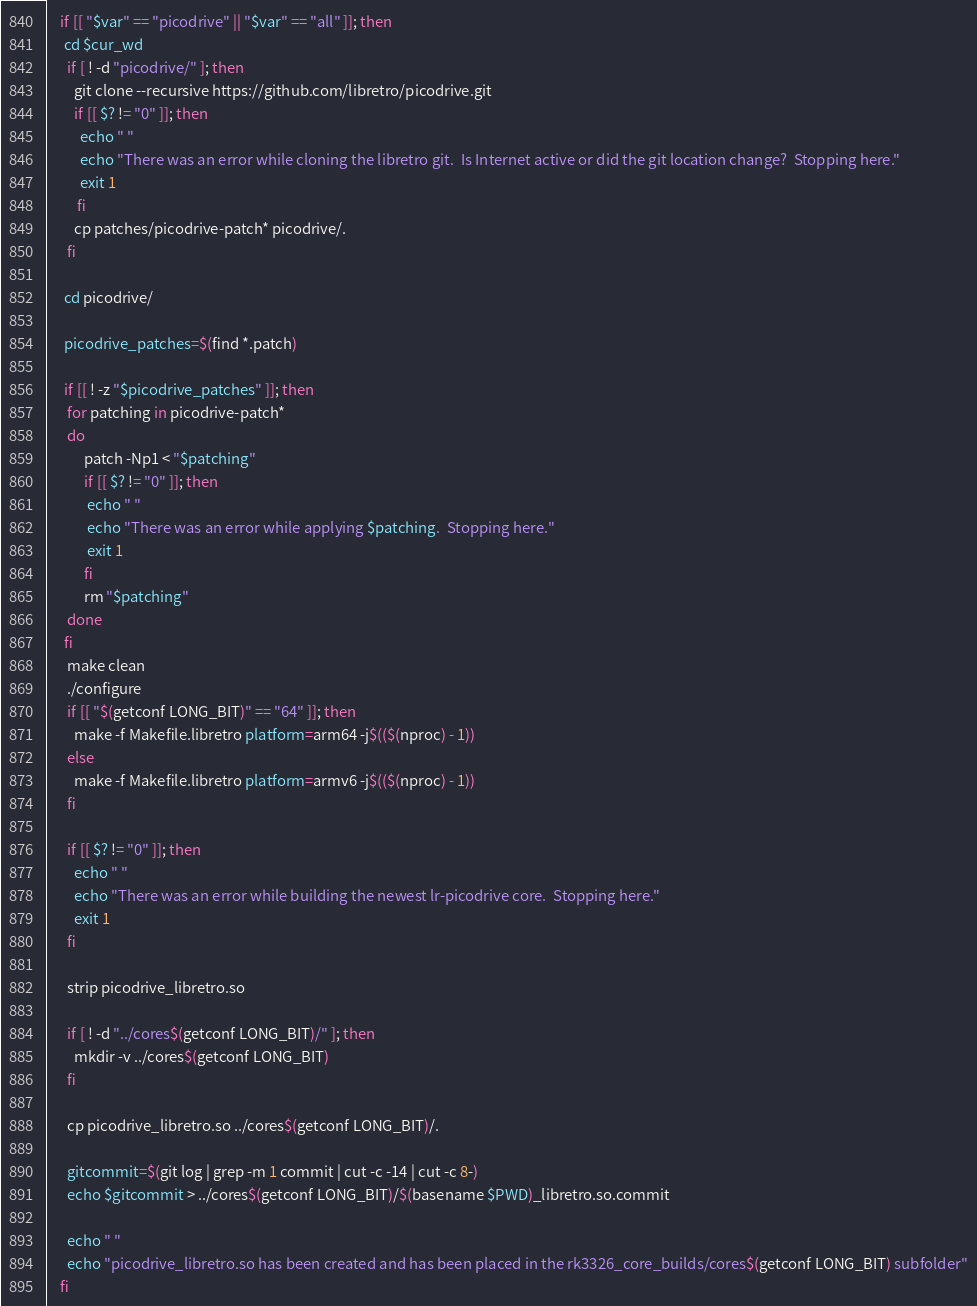Convert code to text. <code><loc_0><loc_0><loc_500><loc_500><_Bash_>	if [[ "$var" == "picodrive" || "$var" == "all" ]]; then
	 cd $cur_wd
	  if [ ! -d "picodrive/" ]; then
		git clone --recursive https://github.com/libretro/picodrive.git
		if [[ $? != "0" ]]; then
		  echo " "
		  echo "There was an error while cloning the libretro git.  Is Internet active or did the git location change?  Stopping here."
		  exit 1
		 fi
		cp patches/picodrive-patch* picodrive/.
	  fi

	 cd picodrive/
	 
	 picodrive_patches=$(find *.patch)
	 
	 if [[ ! -z "$picodrive_patches" ]]; then
	  for patching in picodrive-patch*
	  do
		   patch -Np1 < "$patching"
		   if [[ $? != "0" ]]; then
			echo " "
			echo "There was an error while applying $patching.  Stopping here."
			exit 1
		   fi
		   rm "$patching" 
	  done
	 fi
	  make clean
      ./configure
	  if [[ "$(getconf LONG_BIT)" == "64" ]]; then
		make -f Makefile.libretro platform=arm64 -j$(($(nproc) - 1))
	  else
		make -f Makefile.libretro platform=armv6 -j$(($(nproc) - 1))
	  fi

	  if [[ $? != "0" ]]; then
		echo " "
		echo "There was an error while building the newest lr-picodrive core.  Stopping here."
		exit 1
	  fi

	  strip picodrive_libretro.so

	  if [ ! -d "../cores$(getconf LONG_BIT)/" ]; then
		mkdir -v ../cores$(getconf LONG_BIT)
	  fi

	  cp picodrive_libretro.so ../cores$(getconf LONG_BIT)/.

	  gitcommit=$(git log | grep -m 1 commit | cut -c -14 | cut -c 8-)
	  echo $gitcommit > ../cores$(getconf LONG_BIT)/$(basename $PWD)_libretro.so.commit

	  echo " "
	  echo "picodrive_libretro.so has been created and has been placed in the rk3326_core_builds/cores$(getconf LONG_BIT) subfolder"
	fi
</code> 